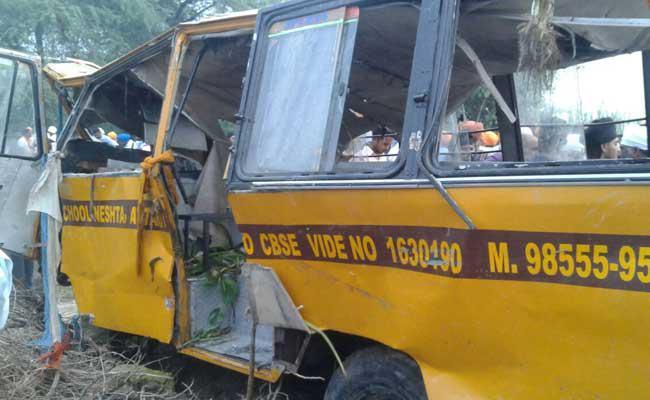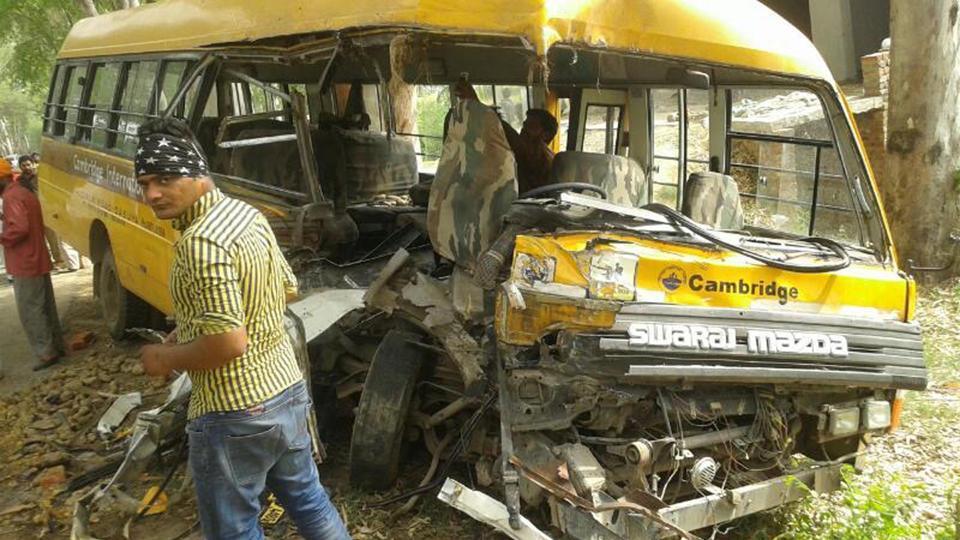The first image is the image on the left, the second image is the image on the right. For the images shown, is this caption "At least one bus is not crashed." true? Answer yes or no. No. The first image is the image on the left, the second image is the image on the right. Assess this claim about the two images: "The left and right image contains the same number of  yellow buses.". Correct or not? Answer yes or no. Yes. 